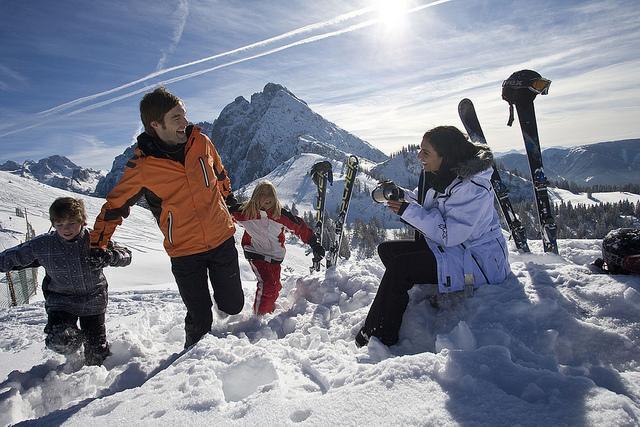What would be the most appropriate beverage for the family to have?
Make your selection and explain in format: 'Answer: answer
Rationale: rationale.'
Options: Milk, iced tea, cola, coffee. Answer: coffee.
Rationale: It is cold outside so a warm liquid can help beat the cold 